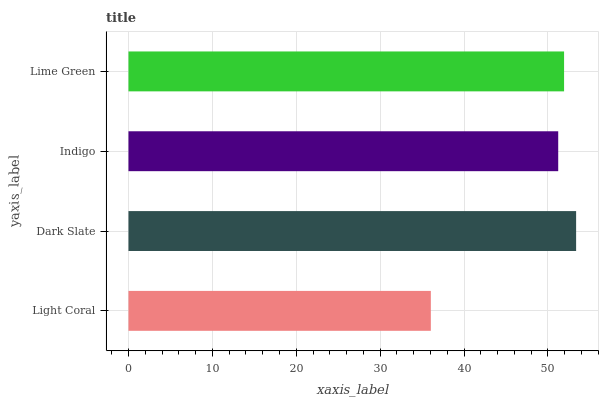Is Light Coral the minimum?
Answer yes or no. Yes. Is Dark Slate the maximum?
Answer yes or no. Yes. Is Indigo the minimum?
Answer yes or no. No. Is Indigo the maximum?
Answer yes or no. No. Is Dark Slate greater than Indigo?
Answer yes or no. Yes. Is Indigo less than Dark Slate?
Answer yes or no. Yes. Is Indigo greater than Dark Slate?
Answer yes or no. No. Is Dark Slate less than Indigo?
Answer yes or no. No. Is Lime Green the high median?
Answer yes or no. Yes. Is Indigo the low median?
Answer yes or no. Yes. Is Dark Slate the high median?
Answer yes or no. No. Is Lime Green the low median?
Answer yes or no. No. 